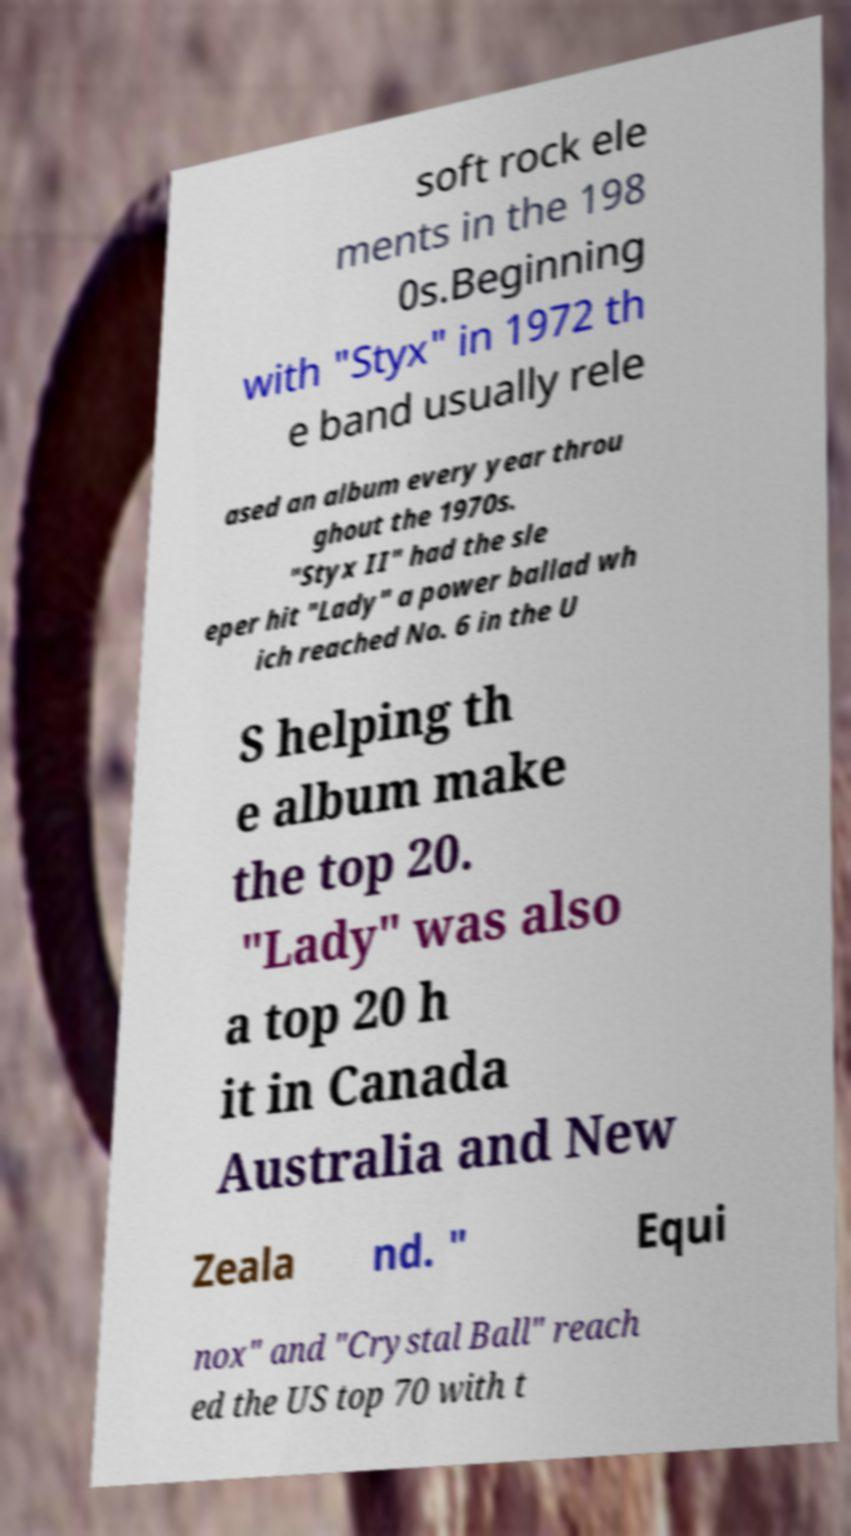Please identify and transcribe the text found in this image. soft rock ele ments in the 198 0s.Beginning with "Styx" in 1972 th e band usually rele ased an album every year throu ghout the 1970s. "Styx II" had the sle eper hit "Lady" a power ballad wh ich reached No. 6 in the U S helping th e album make the top 20. "Lady" was also a top 20 h it in Canada Australia and New Zeala nd. " Equi nox" and "Crystal Ball" reach ed the US top 70 with t 